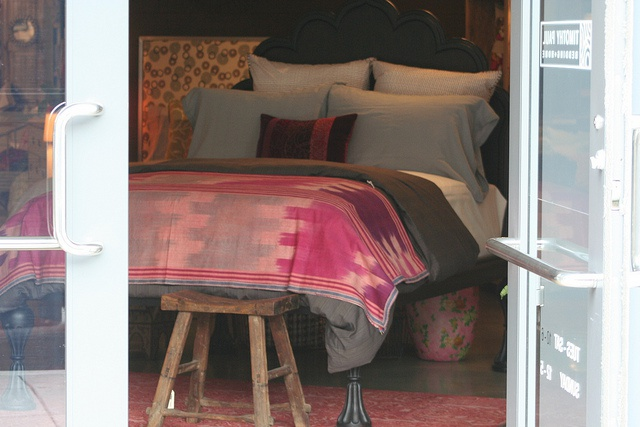Describe the objects in this image and their specific colors. I can see bed in gray, brown, black, and maroon tones and chair in gray, black, brown, and maroon tones in this image. 